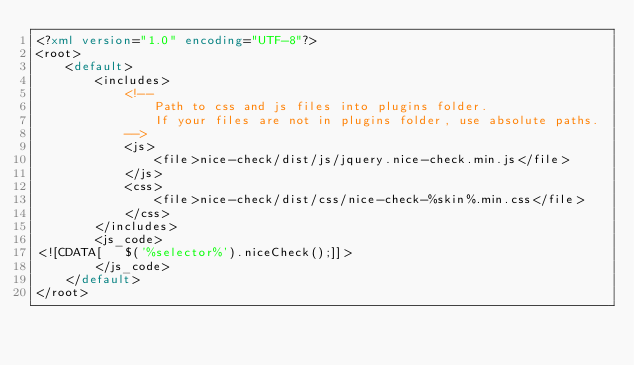<code> <loc_0><loc_0><loc_500><loc_500><_XML_><?xml version="1.0" encoding="UTF-8"?>
<root>
    <default>
        <includes>
            <!--
                Path to css and js files into plugins folder.
                If your files are not in plugins folder, use absolute paths.
            -->
            <js>
                <file>nice-check/dist/js/jquery.nice-check.min.js</file>
            </js>
            <css>
                <file>nice-check/dist/css/nice-check-%skin%.min.css</file>
            </css>
        </includes>
        <js_code>
<![CDATA[   $('%selector%').niceCheck();]]>
        </js_code>
    </default>
</root>
</code> 